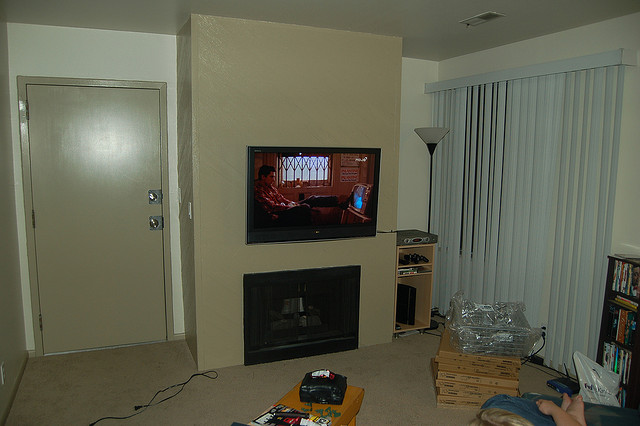<image>What kind of design is on the floor? I don't know what kind of design is on the floor. It could be plain, a carpet, a rug, or even parquet. What kind of design is on the floor? I am not sure what kind of design is on the floor. It can be seen 'carpet', 'plain', 'none', 'rug', 'parquet' or 'solid'. 